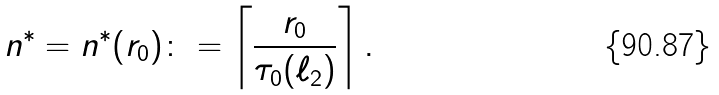Convert formula to latex. <formula><loc_0><loc_0><loc_500><loc_500>n ^ { * } = n ^ { * } ( r _ { 0 } ) \colon = \left \lceil \frac { r _ { 0 } } { \tau _ { 0 } ( \ell _ { 2 } ) } \right \rceil .</formula> 